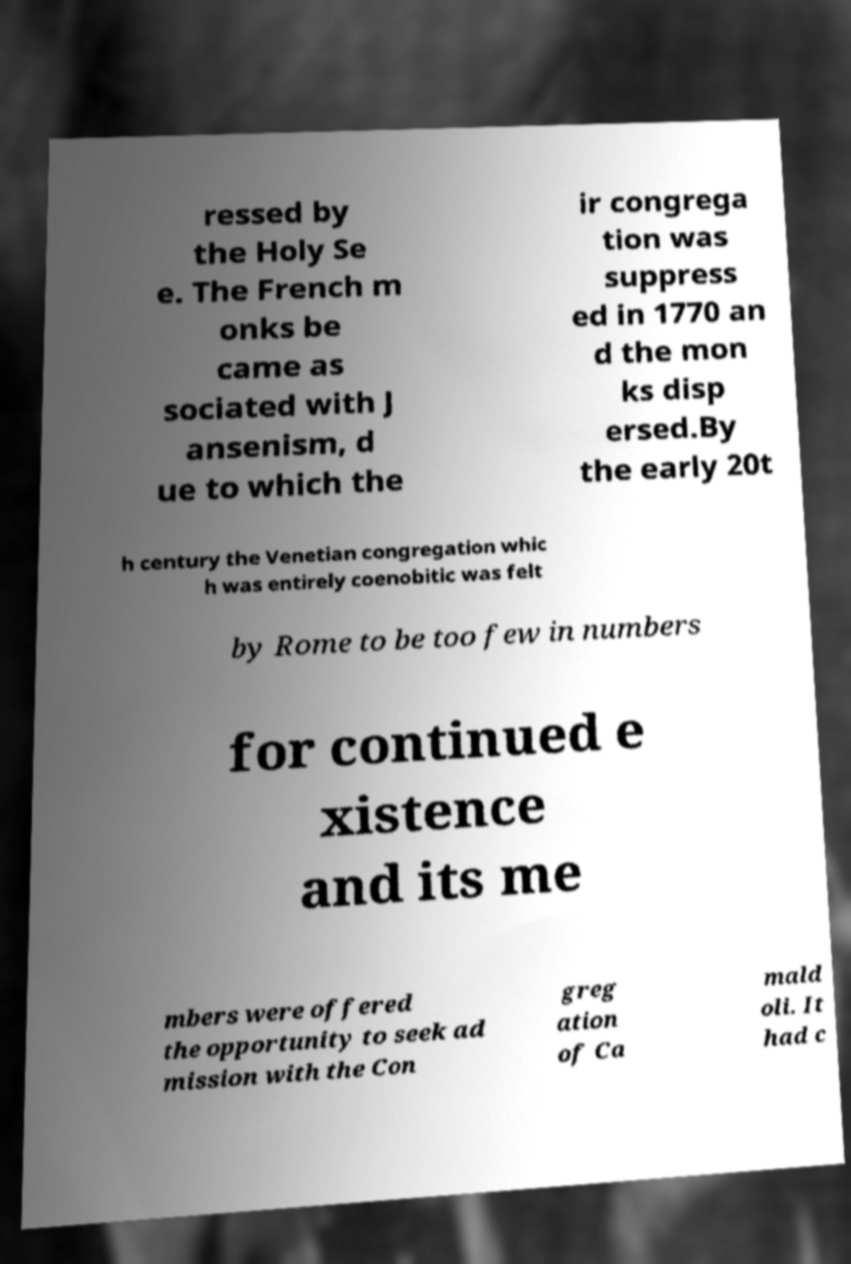For documentation purposes, I need the text within this image transcribed. Could you provide that? ressed by the Holy Se e. The French m onks be came as sociated with J ansenism, d ue to which the ir congrega tion was suppress ed in 1770 an d the mon ks disp ersed.By the early 20t h century the Venetian congregation whic h was entirely coenobitic was felt by Rome to be too few in numbers for continued e xistence and its me mbers were offered the opportunity to seek ad mission with the Con greg ation of Ca mald oli. It had c 